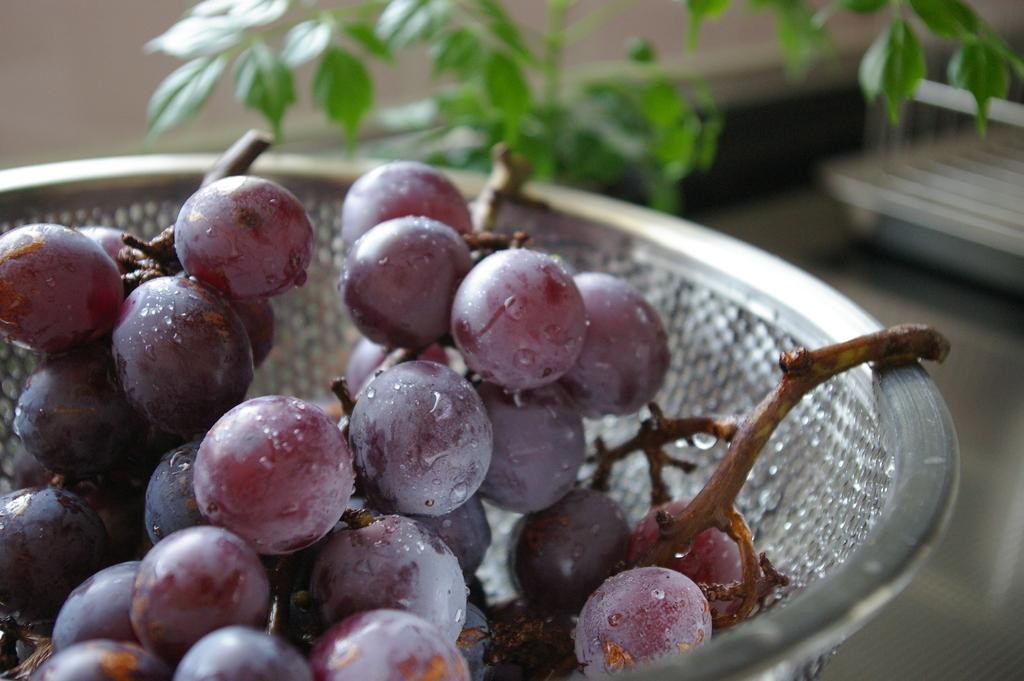What is the main object in the center of the image? There is a bowl in the center of the image. What is inside the bowl? The bowl contains grapes. What can be seen in the background of the image? There is a plant visible in the background of the image. Where is the kitty playing with the yoke in the image? There is no kitty or yoke present in the image; it only features a bowl of grapes and a plant in the background. 